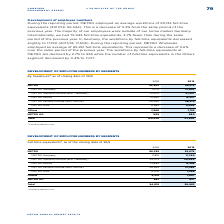According to Metro Ag's financial document, When were the employee numbers by segments calculated? as of the closing date of 30/9. The document states: "Full-time equivalents 1 as of the closing date of 30/9..." Also, What was excluded in the full-time equivalents as of the closing date of 30/9? According to the financial document, METRO China.. The relevant text states: "1 Excluding METRO China...." Also, What were the components under METRO in the table when accounting for the employee numbers by segments? The document contains multiple relevant values: METRO Germany, METRO Western Europe (excl.Germany), METRO Russia, METRO Eastern Europe (excl.Russia), METRO Asia. From the document: "METRO Germany 11,816 11,760 METRO Russia 13,884 12,288 METRO Asia 8,202 7,298..." Additionally, In which year was the amount for METRO AG larger? According to the financial document, 2018. The relevant text states: "2018 2019..." Also, can you calculate: What was the change in METRO AG in 2019 from 2018? Based on the calculation: 837-863, the result is -26. This is based on the information: "METRO AG 863 837 METRO AG 863 837..." The key data points involved are: 837, 863. Also, can you calculate: What was the percentage change in METRO AG in 2019 from 2018? To answer this question, I need to perform calculations using the financial data. The calculation is: (837-863)/863, which equals -3.01 (percentage). This is based on the information: "METRO AG 863 837 METRO AG 863 837..." The key data points involved are: 837, 863. 